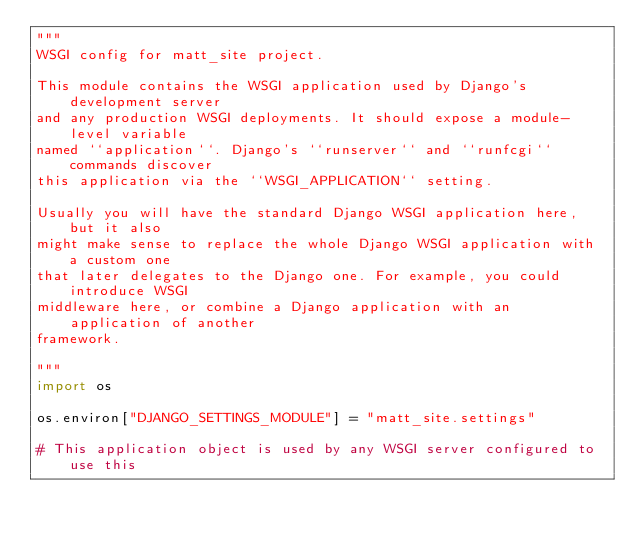<code> <loc_0><loc_0><loc_500><loc_500><_Python_>"""
WSGI config for matt_site project.

This module contains the WSGI application used by Django's development server
and any production WSGI deployments. It should expose a module-level variable
named ``application``. Django's ``runserver`` and ``runfcgi`` commands discover
this application via the ``WSGI_APPLICATION`` setting.

Usually you will have the standard Django WSGI application here, but it also
might make sense to replace the whole Django WSGI application with a custom one
that later delegates to the Django one. For example, you could introduce WSGI
middleware here, or combine a Django application with an application of another
framework.

"""
import os

os.environ["DJANGO_SETTINGS_MODULE"] = "matt_site.settings"

# This application object is used by any WSGI server configured to use this</code> 